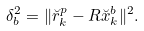<formula> <loc_0><loc_0><loc_500><loc_500>\delta _ { b } ^ { 2 } = \| \breve { r } _ { k } ^ { p } - R \breve { x } _ { k } ^ { b } \| ^ { 2 } .</formula> 